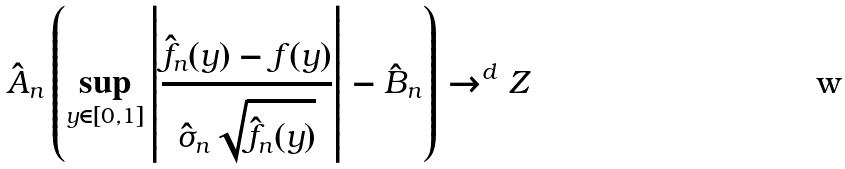Convert formula to latex. <formula><loc_0><loc_0><loc_500><loc_500>\hat { A } _ { n } \left ( \sup _ { y \in [ 0 , 1 ] } \left | \frac { \hat { f } _ { n } ( y ) - f ( y ) } { \hat { \sigma } _ { n } \sqrt { \hat { f } _ { n } ( y ) } } \right | - \hat { B } _ { n } \right ) \to ^ { d } Z</formula> 